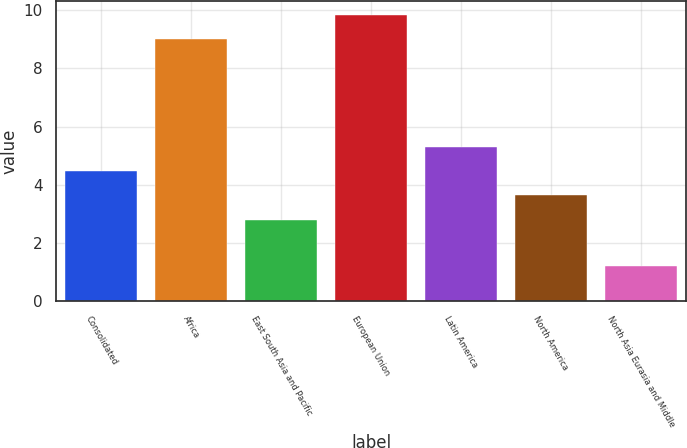Convert chart to OTSL. <chart><loc_0><loc_0><loc_500><loc_500><bar_chart><fcel>Consolidated<fcel>Africa<fcel>East South Asia and Pacific<fcel>European Union<fcel>Latin America<fcel>North America<fcel>North Asia Eurasia and Middle<nl><fcel>4.46<fcel>9<fcel>2.8<fcel>9.83<fcel>5.29<fcel>3.63<fcel>1.2<nl></chart> 